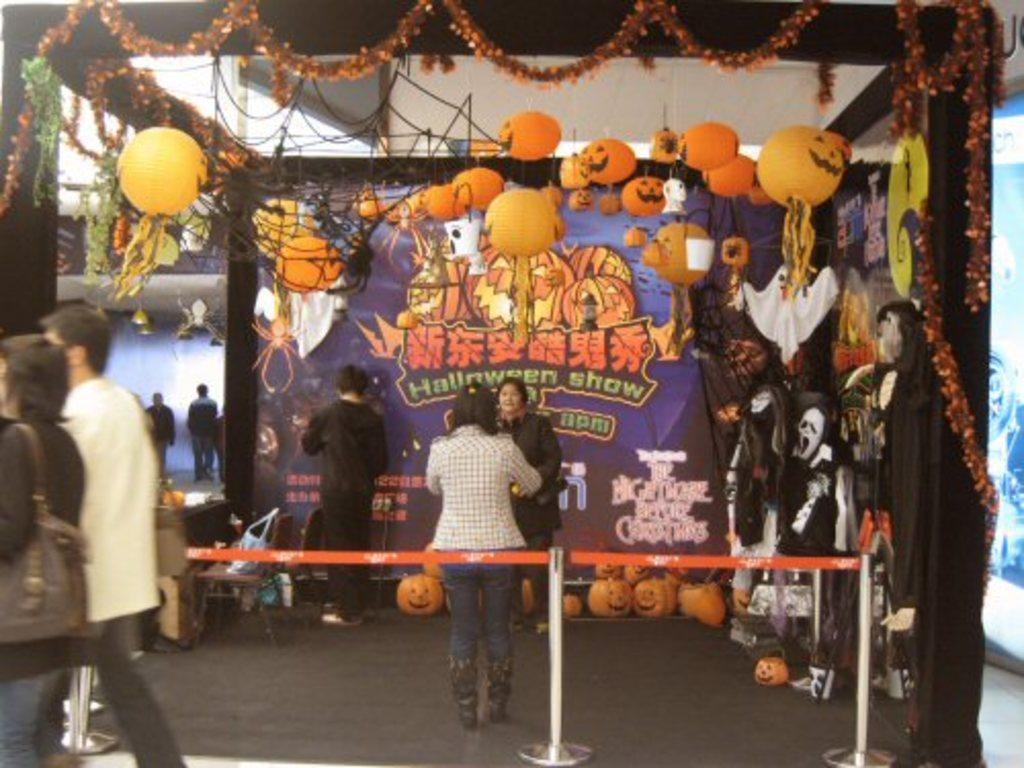How would you summarize this image in a sentence or two? This image is taken indoors. At the bottom of the image there is a floor. In the background there is a wall and there is a banner with a few images and there is a text on it. There are many decorative items and there are many paper lamps. In the middle of the image there are a few pumpkins on the floor. There are many objects on the floor. A few people are standing on the floor. On the left side of the image a man and a woman are walking on the floor. 